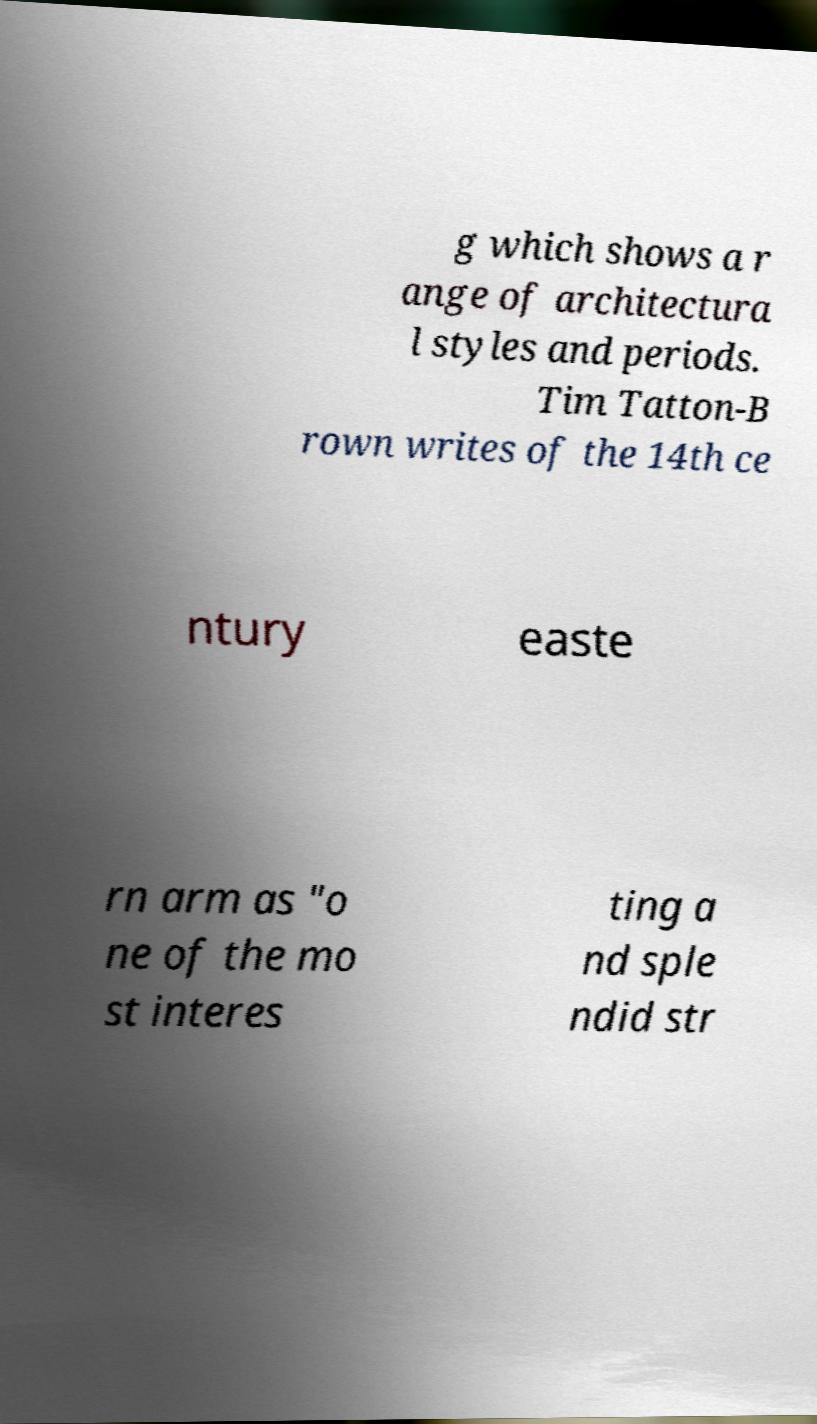Could you assist in decoding the text presented in this image and type it out clearly? g which shows a r ange of architectura l styles and periods. Tim Tatton-B rown writes of the 14th ce ntury easte rn arm as "o ne of the mo st interes ting a nd sple ndid str 